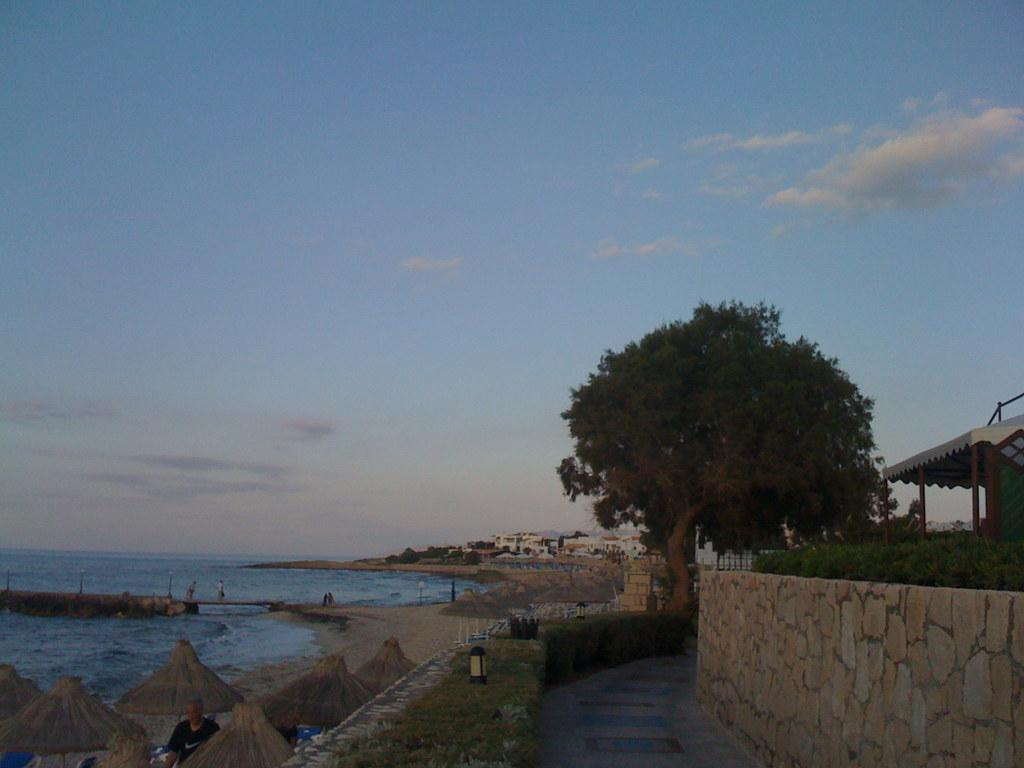What type of vegetation can be seen in the image? There is a tree and a plant in the image. What structure is present in the image that serves as a barrier or divider? There is a boundary wall in the image. What type of shelter is visible in the image? There is a shelter in the image. What type of structures can be seen in the background of the image? There are buildings in the image. What type of ground cover is present in the image? There is grass in the image. What type of portable shade is present in the image? There are umbrellas in the image. What type of natural body of water is visible in the image? There is sea in the image. How would you describe the sky in the image? The sky is blue with clouds. What language is spoken by the people in the image? There are no people visible in the image, so it is impossible to determine the language spoken. What type of stamp is visible on the tree in the image? There is no stamp present on the tree in the image. 